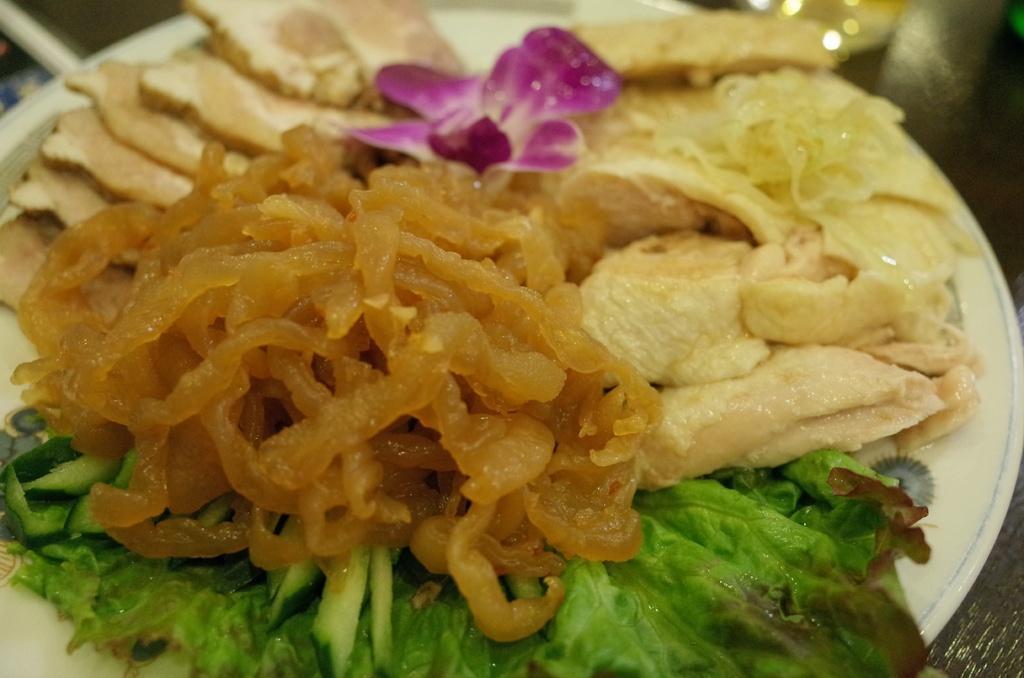In one or two sentences, can you explain what this image depicts? It is a zoomed in picture of a plate of food items. We can also see the flower. 